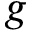<formula> <loc_0><loc_0><loc_500><loc_500>g</formula> 